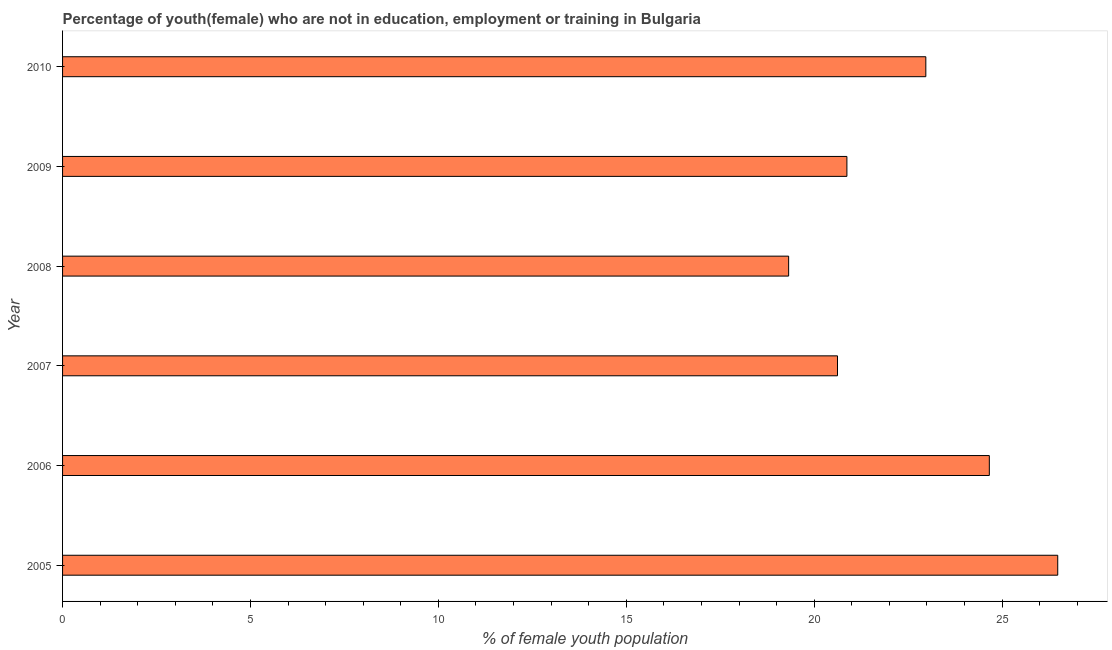Does the graph contain grids?
Your answer should be compact. No. What is the title of the graph?
Give a very brief answer. Percentage of youth(female) who are not in education, employment or training in Bulgaria. What is the label or title of the X-axis?
Provide a succinct answer. % of female youth population. What is the unemployed female youth population in 2006?
Ensure brevity in your answer.  24.66. Across all years, what is the maximum unemployed female youth population?
Your answer should be very brief. 26.48. Across all years, what is the minimum unemployed female youth population?
Ensure brevity in your answer.  19.32. In which year was the unemployed female youth population minimum?
Provide a short and direct response. 2008. What is the sum of the unemployed female youth population?
Your response must be concise. 134.92. What is the difference between the unemployed female youth population in 2005 and 2009?
Your answer should be very brief. 5.61. What is the average unemployed female youth population per year?
Make the answer very short. 22.49. What is the median unemployed female youth population?
Your answer should be very brief. 21.92. Do a majority of the years between 2007 and 2005 (inclusive) have unemployed female youth population greater than 14 %?
Offer a terse response. Yes. What is the ratio of the unemployed female youth population in 2006 to that in 2010?
Offer a terse response. 1.07. Is the unemployed female youth population in 2006 less than that in 2010?
Make the answer very short. No. Is the difference between the unemployed female youth population in 2008 and 2009 greater than the difference between any two years?
Provide a short and direct response. No. What is the difference between the highest and the second highest unemployed female youth population?
Your answer should be very brief. 1.82. Is the sum of the unemployed female youth population in 2006 and 2007 greater than the maximum unemployed female youth population across all years?
Your answer should be very brief. Yes. What is the difference between the highest and the lowest unemployed female youth population?
Offer a terse response. 7.16. Are all the bars in the graph horizontal?
Your response must be concise. Yes. Are the values on the major ticks of X-axis written in scientific E-notation?
Your response must be concise. No. What is the % of female youth population of 2005?
Your answer should be very brief. 26.48. What is the % of female youth population of 2006?
Give a very brief answer. 24.66. What is the % of female youth population in 2007?
Give a very brief answer. 20.62. What is the % of female youth population in 2008?
Your answer should be compact. 19.32. What is the % of female youth population in 2009?
Ensure brevity in your answer.  20.87. What is the % of female youth population in 2010?
Ensure brevity in your answer.  22.97. What is the difference between the % of female youth population in 2005 and 2006?
Provide a succinct answer. 1.82. What is the difference between the % of female youth population in 2005 and 2007?
Keep it short and to the point. 5.86. What is the difference between the % of female youth population in 2005 and 2008?
Ensure brevity in your answer.  7.16. What is the difference between the % of female youth population in 2005 and 2009?
Provide a short and direct response. 5.61. What is the difference between the % of female youth population in 2005 and 2010?
Provide a short and direct response. 3.51. What is the difference between the % of female youth population in 2006 and 2007?
Give a very brief answer. 4.04. What is the difference between the % of female youth population in 2006 and 2008?
Offer a terse response. 5.34. What is the difference between the % of female youth population in 2006 and 2009?
Keep it short and to the point. 3.79. What is the difference between the % of female youth population in 2006 and 2010?
Give a very brief answer. 1.69. What is the difference between the % of female youth population in 2007 and 2008?
Make the answer very short. 1.3. What is the difference between the % of female youth population in 2007 and 2009?
Offer a very short reply. -0.25. What is the difference between the % of female youth population in 2007 and 2010?
Ensure brevity in your answer.  -2.35. What is the difference between the % of female youth population in 2008 and 2009?
Ensure brevity in your answer.  -1.55. What is the difference between the % of female youth population in 2008 and 2010?
Your answer should be compact. -3.65. What is the difference between the % of female youth population in 2009 and 2010?
Your response must be concise. -2.1. What is the ratio of the % of female youth population in 2005 to that in 2006?
Ensure brevity in your answer.  1.07. What is the ratio of the % of female youth population in 2005 to that in 2007?
Offer a terse response. 1.28. What is the ratio of the % of female youth population in 2005 to that in 2008?
Provide a short and direct response. 1.37. What is the ratio of the % of female youth population in 2005 to that in 2009?
Ensure brevity in your answer.  1.27. What is the ratio of the % of female youth population in 2005 to that in 2010?
Provide a succinct answer. 1.15. What is the ratio of the % of female youth population in 2006 to that in 2007?
Provide a succinct answer. 1.2. What is the ratio of the % of female youth population in 2006 to that in 2008?
Make the answer very short. 1.28. What is the ratio of the % of female youth population in 2006 to that in 2009?
Provide a short and direct response. 1.18. What is the ratio of the % of female youth population in 2006 to that in 2010?
Offer a very short reply. 1.07. What is the ratio of the % of female youth population in 2007 to that in 2008?
Your response must be concise. 1.07. What is the ratio of the % of female youth population in 2007 to that in 2010?
Ensure brevity in your answer.  0.9. What is the ratio of the % of female youth population in 2008 to that in 2009?
Offer a terse response. 0.93. What is the ratio of the % of female youth population in 2008 to that in 2010?
Your response must be concise. 0.84. What is the ratio of the % of female youth population in 2009 to that in 2010?
Your answer should be compact. 0.91. 